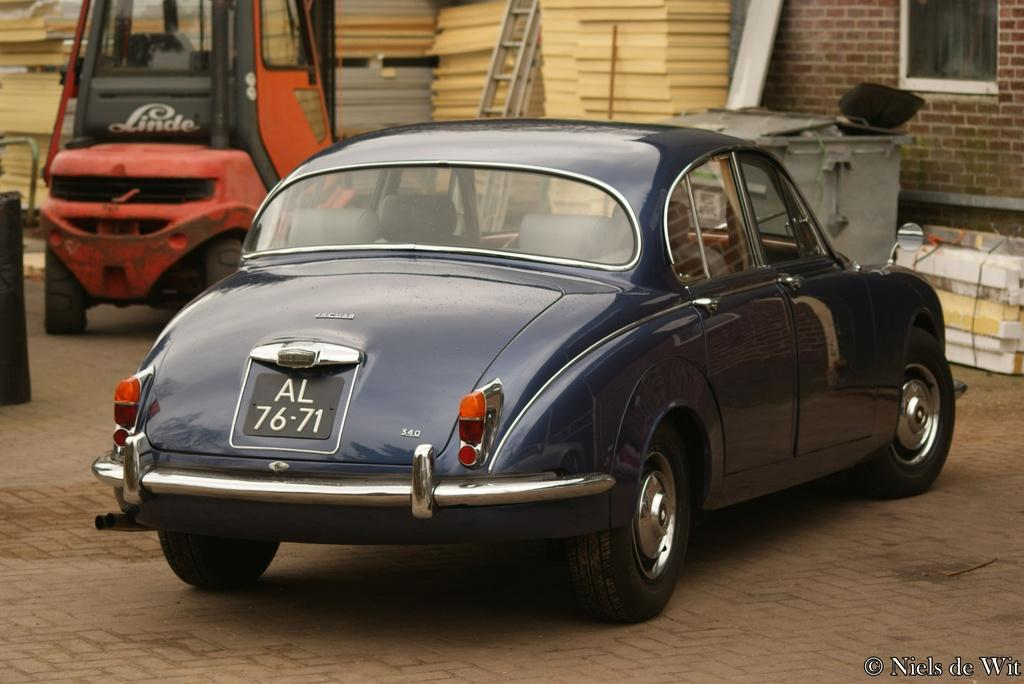What type of vehicle is visible on the surface in the image? There is a car on the surface in the image. What structures can be seen in the image? There is a wall and a window in the image. What objects are present in the background of the image? There is a ladder and another vehicle in the background of the image. What type of pencil can be seen in the image? There is no pencil present in the image. Is the tin visible in the image? There is no tin present in the image. 